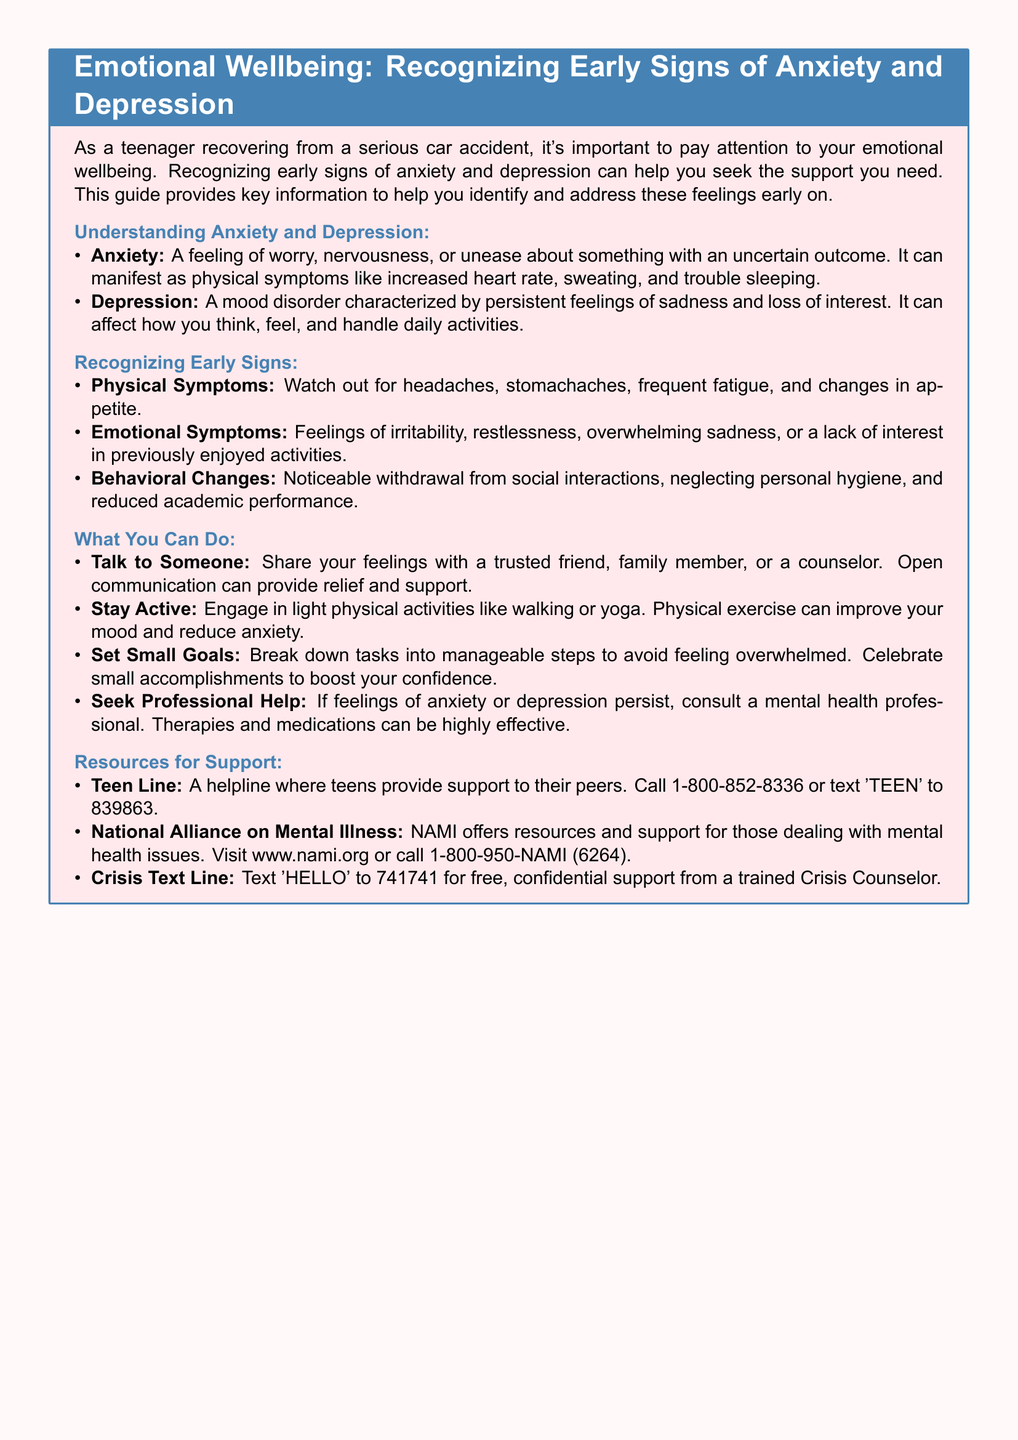What are the physical symptoms of anxiety and depression? The document lists headaches, stomachaches, frequent fatigue, and changes in appetite as physical symptoms.
Answer: Headaches, stomachaches, frequent fatigue, changes in appetite What can you do to improve your mood? The document suggests engaging in light physical activities like walking or yoga to improve mood.
Answer: Light physical activities What’s a recommended helpline for teens? The document mentions the Teen Line, which can be reached at 1-800-852-8336 or by texting 'TEEN' to 839863.
Answer: 1-800-852-8336 What are emotional symptoms of anxiety and depression? The document cites feelings of irritability, restlessness, overwhelming sadness, or lack of interest in activities as emotional symptoms.
Answer: Irritability, restlessness, overwhelming sadness, lack of interest What should you do if feelings persist? The document advises to consult a mental health professional if feelings of anxiety or depression persist.
Answer: Consult a mental health professional What is the title of the document? The title specified in the document is "Emotional Wellbeing: Recognizing Early Signs of Anxiety and Depression."
Answer: Emotional Wellbeing: Recognizing Early Signs of Anxiety and Depression What is a small goal you can set? The document encourages breaking down tasks into manageable steps as a way to set small goals.
Answer: Manageable steps What organization offers resources for mental health issues? The document refers to the National Alliance on Mental Illness (NAMI) as an organization providing resources for mental health.
Answer: National Alliance on Mental Illness (NAMI) 